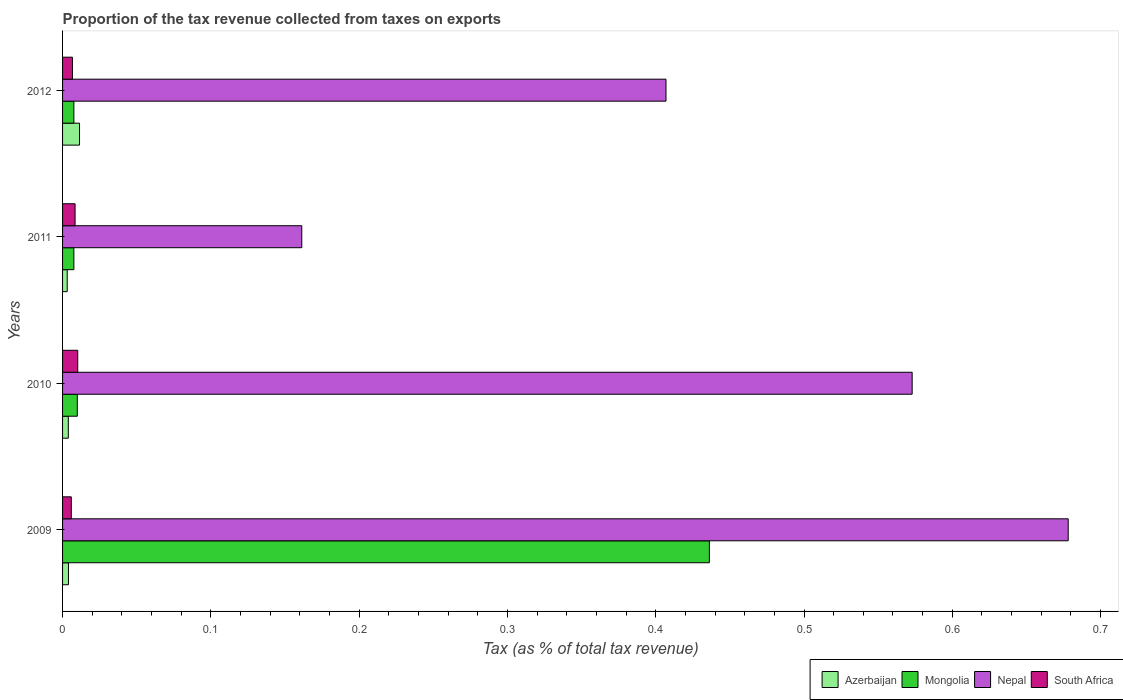Are the number of bars per tick equal to the number of legend labels?
Your answer should be very brief. Yes. Are the number of bars on each tick of the Y-axis equal?
Your answer should be compact. Yes. How many bars are there on the 1st tick from the bottom?
Offer a terse response. 4. What is the proportion of the tax revenue collected in South Africa in 2011?
Offer a terse response. 0.01. Across all years, what is the maximum proportion of the tax revenue collected in South Africa?
Your answer should be compact. 0.01. Across all years, what is the minimum proportion of the tax revenue collected in Mongolia?
Offer a terse response. 0.01. In which year was the proportion of the tax revenue collected in Nepal maximum?
Ensure brevity in your answer.  2009. In which year was the proportion of the tax revenue collected in Nepal minimum?
Your answer should be very brief. 2011. What is the total proportion of the tax revenue collected in Azerbaijan in the graph?
Your answer should be compact. 0.02. What is the difference between the proportion of the tax revenue collected in South Africa in 2010 and that in 2012?
Offer a very short reply. 0. What is the difference between the proportion of the tax revenue collected in Nepal in 2010 and the proportion of the tax revenue collected in South Africa in 2012?
Provide a succinct answer. 0.57. What is the average proportion of the tax revenue collected in Nepal per year?
Offer a very short reply. 0.45. In the year 2010, what is the difference between the proportion of the tax revenue collected in South Africa and proportion of the tax revenue collected in Azerbaijan?
Give a very brief answer. 0.01. What is the ratio of the proportion of the tax revenue collected in Nepal in 2010 to that in 2011?
Keep it short and to the point. 3.55. Is the proportion of the tax revenue collected in South Africa in 2009 less than that in 2011?
Make the answer very short. Yes. Is the difference between the proportion of the tax revenue collected in South Africa in 2010 and 2012 greater than the difference between the proportion of the tax revenue collected in Azerbaijan in 2010 and 2012?
Ensure brevity in your answer.  Yes. What is the difference between the highest and the second highest proportion of the tax revenue collected in Mongolia?
Give a very brief answer. 0.43. What is the difference between the highest and the lowest proportion of the tax revenue collected in South Africa?
Keep it short and to the point. 0. Is the sum of the proportion of the tax revenue collected in South Africa in 2009 and 2010 greater than the maximum proportion of the tax revenue collected in Nepal across all years?
Your response must be concise. No. What does the 2nd bar from the top in 2012 represents?
Give a very brief answer. Nepal. What does the 1st bar from the bottom in 2010 represents?
Ensure brevity in your answer.  Azerbaijan. Are all the bars in the graph horizontal?
Offer a very short reply. Yes. Where does the legend appear in the graph?
Offer a terse response. Bottom right. What is the title of the graph?
Your answer should be compact. Proportion of the tax revenue collected from taxes on exports. What is the label or title of the X-axis?
Provide a succinct answer. Tax (as % of total tax revenue). What is the Tax (as % of total tax revenue) in Azerbaijan in 2009?
Your answer should be compact. 0. What is the Tax (as % of total tax revenue) in Mongolia in 2009?
Give a very brief answer. 0.44. What is the Tax (as % of total tax revenue) in Nepal in 2009?
Give a very brief answer. 0.68. What is the Tax (as % of total tax revenue) in South Africa in 2009?
Make the answer very short. 0.01. What is the Tax (as % of total tax revenue) of Azerbaijan in 2010?
Ensure brevity in your answer.  0. What is the Tax (as % of total tax revenue) of Mongolia in 2010?
Keep it short and to the point. 0.01. What is the Tax (as % of total tax revenue) of Nepal in 2010?
Offer a terse response. 0.57. What is the Tax (as % of total tax revenue) in South Africa in 2010?
Provide a short and direct response. 0.01. What is the Tax (as % of total tax revenue) of Azerbaijan in 2011?
Offer a terse response. 0. What is the Tax (as % of total tax revenue) in Mongolia in 2011?
Ensure brevity in your answer.  0.01. What is the Tax (as % of total tax revenue) of Nepal in 2011?
Your answer should be very brief. 0.16. What is the Tax (as % of total tax revenue) in South Africa in 2011?
Your answer should be compact. 0.01. What is the Tax (as % of total tax revenue) of Azerbaijan in 2012?
Your answer should be compact. 0.01. What is the Tax (as % of total tax revenue) of Mongolia in 2012?
Offer a very short reply. 0.01. What is the Tax (as % of total tax revenue) of Nepal in 2012?
Provide a short and direct response. 0.41. What is the Tax (as % of total tax revenue) of South Africa in 2012?
Your answer should be very brief. 0.01. Across all years, what is the maximum Tax (as % of total tax revenue) of Azerbaijan?
Keep it short and to the point. 0.01. Across all years, what is the maximum Tax (as % of total tax revenue) in Mongolia?
Your response must be concise. 0.44. Across all years, what is the maximum Tax (as % of total tax revenue) in Nepal?
Give a very brief answer. 0.68. Across all years, what is the maximum Tax (as % of total tax revenue) of South Africa?
Give a very brief answer. 0.01. Across all years, what is the minimum Tax (as % of total tax revenue) of Azerbaijan?
Keep it short and to the point. 0. Across all years, what is the minimum Tax (as % of total tax revenue) in Mongolia?
Your response must be concise. 0.01. Across all years, what is the minimum Tax (as % of total tax revenue) of Nepal?
Give a very brief answer. 0.16. Across all years, what is the minimum Tax (as % of total tax revenue) of South Africa?
Offer a very short reply. 0.01. What is the total Tax (as % of total tax revenue) in Azerbaijan in the graph?
Provide a short and direct response. 0.02. What is the total Tax (as % of total tax revenue) of Mongolia in the graph?
Provide a short and direct response. 0.46. What is the total Tax (as % of total tax revenue) in Nepal in the graph?
Make the answer very short. 1.82. What is the total Tax (as % of total tax revenue) of South Africa in the graph?
Ensure brevity in your answer.  0.03. What is the difference between the Tax (as % of total tax revenue) in Azerbaijan in 2009 and that in 2010?
Ensure brevity in your answer.  0. What is the difference between the Tax (as % of total tax revenue) in Mongolia in 2009 and that in 2010?
Offer a very short reply. 0.43. What is the difference between the Tax (as % of total tax revenue) of Nepal in 2009 and that in 2010?
Provide a succinct answer. 0.11. What is the difference between the Tax (as % of total tax revenue) in South Africa in 2009 and that in 2010?
Your response must be concise. -0. What is the difference between the Tax (as % of total tax revenue) of Azerbaijan in 2009 and that in 2011?
Your response must be concise. 0. What is the difference between the Tax (as % of total tax revenue) in Mongolia in 2009 and that in 2011?
Keep it short and to the point. 0.43. What is the difference between the Tax (as % of total tax revenue) in Nepal in 2009 and that in 2011?
Provide a short and direct response. 0.52. What is the difference between the Tax (as % of total tax revenue) of South Africa in 2009 and that in 2011?
Offer a very short reply. -0. What is the difference between the Tax (as % of total tax revenue) of Azerbaijan in 2009 and that in 2012?
Offer a terse response. -0.01. What is the difference between the Tax (as % of total tax revenue) of Mongolia in 2009 and that in 2012?
Make the answer very short. 0.43. What is the difference between the Tax (as % of total tax revenue) of Nepal in 2009 and that in 2012?
Your response must be concise. 0.27. What is the difference between the Tax (as % of total tax revenue) of South Africa in 2009 and that in 2012?
Ensure brevity in your answer.  -0. What is the difference between the Tax (as % of total tax revenue) in Azerbaijan in 2010 and that in 2011?
Ensure brevity in your answer.  0. What is the difference between the Tax (as % of total tax revenue) of Mongolia in 2010 and that in 2011?
Make the answer very short. 0. What is the difference between the Tax (as % of total tax revenue) of Nepal in 2010 and that in 2011?
Provide a short and direct response. 0.41. What is the difference between the Tax (as % of total tax revenue) of South Africa in 2010 and that in 2011?
Give a very brief answer. 0. What is the difference between the Tax (as % of total tax revenue) of Azerbaijan in 2010 and that in 2012?
Ensure brevity in your answer.  -0.01. What is the difference between the Tax (as % of total tax revenue) in Mongolia in 2010 and that in 2012?
Offer a very short reply. 0. What is the difference between the Tax (as % of total tax revenue) in Nepal in 2010 and that in 2012?
Make the answer very short. 0.17. What is the difference between the Tax (as % of total tax revenue) in South Africa in 2010 and that in 2012?
Provide a succinct answer. 0. What is the difference between the Tax (as % of total tax revenue) in Azerbaijan in 2011 and that in 2012?
Your answer should be very brief. -0.01. What is the difference between the Tax (as % of total tax revenue) in Mongolia in 2011 and that in 2012?
Ensure brevity in your answer.  -0. What is the difference between the Tax (as % of total tax revenue) in Nepal in 2011 and that in 2012?
Offer a very short reply. -0.25. What is the difference between the Tax (as % of total tax revenue) of South Africa in 2011 and that in 2012?
Your answer should be very brief. 0. What is the difference between the Tax (as % of total tax revenue) of Azerbaijan in 2009 and the Tax (as % of total tax revenue) of Mongolia in 2010?
Provide a short and direct response. -0.01. What is the difference between the Tax (as % of total tax revenue) in Azerbaijan in 2009 and the Tax (as % of total tax revenue) in Nepal in 2010?
Keep it short and to the point. -0.57. What is the difference between the Tax (as % of total tax revenue) in Azerbaijan in 2009 and the Tax (as % of total tax revenue) in South Africa in 2010?
Offer a terse response. -0.01. What is the difference between the Tax (as % of total tax revenue) in Mongolia in 2009 and the Tax (as % of total tax revenue) in Nepal in 2010?
Offer a very short reply. -0.14. What is the difference between the Tax (as % of total tax revenue) of Mongolia in 2009 and the Tax (as % of total tax revenue) of South Africa in 2010?
Your answer should be very brief. 0.43. What is the difference between the Tax (as % of total tax revenue) of Nepal in 2009 and the Tax (as % of total tax revenue) of South Africa in 2010?
Provide a short and direct response. 0.67. What is the difference between the Tax (as % of total tax revenue) of Azerbaijan in 2009 and the Tax (as % of total tax revenue) of Mongolia in 2011?
Provide a short and direct response. -0. What is the difference between the Tax (as % of total tax revenue) in Azerbaijan in 2009 and the Tax (as % of total tax revenue) in Nepal in 2011?
Your answer should be compact. -0.16. What is the difference between the Tax (as % of total tax revenue) in Azerbaijan in 2009 and the Tax (as % of total tax revenue) in South Africa in 2011?
Offer a very short reply. -0. What is the difference between the Tax (as % of total tax revenue) in Mongolia in 2009 and the Tax (as % of total tax revenue) in Nepal in 2011?
Provide a succinct answer. 0.27. What is the difference between the Tax (as % of total tax revenue) in Mongolia in 2009 and the Tax (as % of total tax revenue) in South Africa in 2011?
Offer a terse response. 0.43. What is the difference between the Tax (as % of total tax revenue) in Nepal in 2009 and the Tax (as % of total tax revenue) in South Africa in 2011?
Offer a terse response. 0.67. What is the difference between the Tax (as % of total tax revenue) of Azerbaijan in 2009 and the Tax (as % of total tax revenue) of Mongolia in 2012?
Ensure brevity in your answer.  -0. What is the difference between the Tax (as % of total tax revenue) in Azerbaijan in 2009 and the Tax (as % of total tax revenue) in Nepal in 2012?
Your answer should be very brief. -0.4. What is the difference between the Tax (as % of total tax revenue) in Azerbaijan in 2009 and the Tax (as % of total tax revenue) in South Africa in 2012?
Provide a succinct answer. -0. What is the difference between the Tax (as % of total tax revenue) in Mongolia in 2009 and the Tax (as % of total tax revenue) in Nepal in 2012?
Offer a very short reply. 0.03. What is the difference between the Tax (as % of total tax revenue) of Mongolia in 2009 and the Tax (as % of total tax revenue) of South Africa in 2012?
Ensure brevity in your answer.  0.43. What is the difference between the Tax (as % of total tax revenue) of Nepal in 2009 and the Tax (as % of total tax revenue) of South Africa in 2012?
Keep it short and to the point. 0.67. What is the difference between the Tax (as % of total tax revenue) in Azerbaijan in 2010 and the Tax (as % of total tax revenue) in Mongolia in 2011?
Your answer should be compact. -0. What is the difference between the Tax (as % of total tax revenue) of Azerbaijan in 2010 and the Tax (as % of total tax revenue) of Nepal in 2011?
Make the answer very short. -0.16. What is the difference between the Tax (as % of total tax revenue) of Azerbaijan in 2010 and the Tax (as % of total tax revenue) of South Africa in 2011?
Offer a terse response. -0. What is the difference between the Tax (as % of total tax revenue) of Mongolia in 2010 and the Tax (as % of total tax revenue) of Nepal in 2011?
Offer a terse response. -0.15. What is the difference between the Tax (as % of total tax revenue) of Mongolia in 2010 and the Tax (as % of total tax revenue) of South Africa in 2011?
Provide a short and direct response. 0. What is the difference between the Tax (as % of total tax revenue) in Nepal in 2010 and the Tax (as % of total tax revenue) in South Africa in 2011?
Provide a succinct answer. 0.56. What is the difference between the Tax (as % of total tax revenue) in Azerbaijan in 2010 and the Tax (as % of total tax revenue) in Mongolia in 2012?
Your answer should be very brief. -0. What is the difference between the Tax (as % of total tax revenue) of Azerbaijan in 2010 and the Tax (as % of total tax revenue) of Nepal in 2012?
Your response must be concise. -0.4. What is the difference between the Tax (as % of total tax revenue) of Azerbaijan in 2010 and the Tax (as % of total tax revenue) of South Africa in 2012?
Ensure brevity in your answer.  -0. What is the difference between the Tax (as % of total tax revenue) of Mongolia in 2010 and the Tax (as % of total tax revenue) of Nepal in 2012?
Your response must be concise. -0.4. What is the difference between the Tax (as % of total tax revenue) of Mongolia in 2010 and the Tax (as % of total tax revenue) of South Africa in 2012?
Your answer should be very brief. 0. What is the difference between the Tax (as % of total tax revenue) in Nepal in 2010 and the Tax (as % of total tax revenue) in South Africa in 2012?
Offer a terse response. 0.57. What is the difference between the Tax (as % of total tax revenue) of Azerbaijan in 2011 and the Tax (as % of total tax revenue) of Mongolia in 2012?
Give a very brief answer. -0. What is the difference between the Tax (as % of total tax revenue) of Azerbaijan in 2011 and the Tax (as % of total tax revenue) of Nepal in 2012?
Provide a succinct answer. -0.4. What is the difference between the Tax (as % of total tax revenue) of Azerbaijan in 2011 and the Tax (as % of total tax revenue) of South Africa in 2012?
Give a very brief answer. -0. What is the difference between the Tax (as % of total tax revenue) of Mongolia in 2011 and the Tax (as % of total tax revenue) of Nepal in 2012?
Ensure brevity in your answer.  -0.4. What is the difference between the Tax (as % of total tax revenue) in Nepal in 2011 and the Tax (as % of total tax revenue) in South Africa in 2012?
Offer a very short reply. 0.15. What is the average Tax (as % of total tax revenue) of Azerbaijan per year?
Ensure brevity in your answer.  0.01. What is the average Tax (as % of total tax revenue) of Mongolia per year?
Make the answer very short. 0.12. What is the average Tax (as % of total tax revenue) of Nepal per year?
Keep it short and to the point. 0.45. What is the average Tax (as % of total tax revenue) in South Africa per year?
Offer a terse response. 0.01. In the year 2009, what is the difference between the Tax (as % of total tax revenue) of Azerbaijan and Tax (as % of total tax revenue) of Mongolia?
Make the answer very short. -0.43. In the year 2009, what is the difference between the Tax (as % of total tax revenue) of Azerbaijan and Tax (as % of total tax revenue) of Nepal?
Ensure brevity in your answer.  -0.67. In the year 2009, what is the difference between the Tax (as % of total tax revenue) in Azerbaijan and Tax (as % of total tax revenue) in South Africa?
Keep it short and to the point. -0. In the year 2009, what is the difference between the Tax (as % of total tax revenue) in Mongolia and Tax (as % of total tax revenue) in Nepal?
Make the answer very short. -0.24. In the year 2009, what is the difference between the Tax (as % of total tax revenue) of Mongolia and Tax (as % of total tax revenue) of South Africa?
Your answer should be very brief. 0.43. In the year 2009, what is the difference between the Tax (as % of total tax revenue) in Nepal and Tax (as % of total tax revenue) in South Africa?
Offer a very short reply. 0.67. In the year 2010, what is the difference between the Tax (as % of total tax revenue) of Azerbaijan and Tax (as % of total tax revenue) of Mongolia?
Provide a short and direct response. -0.01. In the year 2010, what is the difference between the Tax (as % of total tax revenue) in Azerbaijan and Tax (as % of total tax revenue) in Nepal?
Ensure brevity in your answer.  -0.57. In the year 2010, what is the difference between the Tax (as % of total tax revenue) of Azerbaijan and Tax (as % of total tax revenue) of South Africa?
Offer a very short reply. -0.01. In the year 2010, what is the difference between the Tax (as % of total tax revenue) of Mongolia and Tax (as % of total tax revenue) of Nepal?
Your answer should be very brief. -0.56. In the year 2010, what is the difference between the Tax (as % of total tax revenue) of Mongolia and Tax (as % of total tax revenue) of South Africa?
Your answer should be compact. -0. In the year 2010, what is the difference between the Tax (as % of total tax revenue) in Nepal and Tax (as % of total tax revenue) in South Africa?
Your answer should be very brief. 0.56. In the year 2011, what is the difference between the Tax (as % of total tax revenue) of Azerbaijan and Tax (as % of total tax revenue) of Mongolia?
Your answer should be compact. -0. In the year 2011, what is the difference between the Tax (as % of total tax revenue) of Azerbaijan and Tax (as % of total tax revenue) of Nepal?
Make the answer very short. -0.16. In the year 2011, what is the difference between the Tax (as % of total tax revenue) in Azerbaijan and Tax (as % of total tax revenue) in South Africa?
Ensure brevity in your answer.  -0.01. In the year 2011, what is the difference between the Tax (as % of total tax revenue) of Mongolia and Tax (as % of total tax revenue) of Nepal?
Your answer should be compact. -0.15. In the year 2011, what is the difference between the Tax (as % of total tax revenue) of Mongolia and Tax (as % of total tax revenue) of South Africa?
Your answer should be very brief. -0. In the year 2011, what is the difference between the Tax (as % of total tax revenue) in Nepal and Tax (as % of total tax revenue) in South Africa?
Your answer should be compact. 0.15. In the year 2012, what is the difference between the Tax (as % of total tax revenue) in Azerbaijan and Tax (as % of total tax revenue) in Mongolia?
Provide a short and direct response. 0. In the year 2012, what is the difference between the Tax (as % of total tax revenue) of Azerbaijan and Tax (as % of total tax revenue) of Nepal?
Offer a terse response. -0.4. In the year 2012, what is the difference between the Tax (as % of total tax revenue) in Azerbaijan and Tax (as % of total tax revenue) in South Africa?
Provide a short and direct response. 0. In the year 2012, what is the difference between the Tax (as % of total tax revenue) in Mongolia and Tax (as % of total tax revenue) in Nepal?
Provide a succinct answer. -0.4. In the year 2012, what is the difference between the Tax (as % of total tax revenue) of Mongolia and Tax (as % of total tax revenue) of South Africa?
Your answer should be compact. 0. In the year 2012, what is the difference between the Tax (as % of total tax revenue) of Nepal and Tax (as % of total tax revenue) of South Africa?
Ensure brevity in your answer.  0.4. What is the ratio of the Tax (as % of total tax revenue) of Azerbaijan in 2009 to that in 2010?
Ensure brevity in your answer.  1.03. What is the ratio of the Tax (as % of total tax revenue) in Mongolia in 2009 to that in 2010?
Provide a succinct answer. 43.93. What is the ratio of the Tax (as % of total tax revenue) of Nepal in 2009 to that in 2010?
Your answer should be compact. 1.18. What is the ratio of the Tax (as % of total tax revenue) in South Africa in 2009 to that in 2010?
Your answer should be very brief. 0.58. What is the ratio of the Tax (as % of total tax revenue) of Azerbaijan in 2009 to that in 2011?
Offer a terse response. 1.27. What is the ratio of the Tax (as % of total tax revenue) in Mongolia in 2009 to that in 2011?
Offer a terse response. 57.21. What is the ratio of the Tax (as % of total tax revenue) of Nepal in 2009 to that in 2011?
Give a very brief answer. 4.2. What is the ratio of the Tax (as % of total tax revenue) in South Africa in 2009 to that in 2011?
Your answer should be compact. 0.7. What is the ratio of the Tax (as % of total tax revenue) in Azerbaijan in 2009 to that in 2012?
Your response must be concise. 0.35. What is the ratio of the Tax (as % of total tax revenue) in Mongolia in 2009 to that in 2012?
Give a very brief answer. 57.09. What is the ratio of the Tax (as % of total tax revenue) in Nepal in 2009 to that in 2012?
Provide a short and direct response. 1.67. What is the ratio of the Tax (as % of total tax revenue) in South Africa in 2009 to that in 2012?
Make the answer very short. 0.88. What is the ratio of the Tax (as % of total tax revenue) of Azerbaijan in 2010 to that in 2011?
Make the answer very short. 1.23. What is the ratio of the Tax (as % of total tax revenue) of Mongolia in 2010 to that in 2011?
Your response must be concise. 1.3. What is the ratio of the Tax (as % of total tax revenue) in Nepal in 2010 to that in 2011?
Your answer should be compact. 3.55. What is the ratio of the Tax (as % of total tax revenue) of South Africa in 2010 to that in 2011?
Give a very brief answer. 1.21. What is the ratio of the Tax (as % of total tax revenue) in Azerbaijan in 2010 to that in 2012?
Keep it short and to the point. 0.34. What is the ratio of the Tax (as % of total tax revenue) in Mongolia in 2010 to that in 2012?
Make the answer very short. 1.3. What is the ratio of the Tax (as % of total tax revenue) in Nepal in 2010 to that in 2012?
Provide a short and direct response. 1.41. What is the ratio of the Tax (as % of total tax revenue) of South Africa in 2010 to that in 2012?
Make the answer very short. 1.54. What is the ratio of the Tax (as % of total tax revenue) in Azerbaijan in 2011 to that in 2012?
Your answer should be compact. 0.27. What is the ratio of the Tax (as % of total tax revenue) in Mongolia in 2011 to that in 2012?
Your response must be concise. 1. What is the ratio of the Tax (as % of total tax revenue) of Nepal in 2011 to that in 2012?
Your response must be concise. 0.4. What is the ratio of the Tax (as % of total tax revenue) of South Africa in 2011 to that in 2012?
Ensure brevity in your answer.  1.27. What is the difference between the highest and the second highest Tax (as % of total tax revenue) of Azerbaijan?
Your answer should be compact. 0.01. What is the difference between the highest and the second highest Tax (as % of total tax revenue) of Mongolia?
Keep it short and to the point. 0.43. What is the difference between the highest and the second highest Tax (as % of total tax revenue) of Nepal?
Offer a very short reply. 0.11. What is the difference between the highest and the second highest Tax (as % of total tax revenue) of South Africa?
Offer a terse response. 0. What is the difference between the highest and the lowest Tax (as % of total tax revenue) of Azerbaijan?
Make the answer very short. 0.01. What is the difference between the highest and the lowest Tax (as % of total tax revenue) of Mongolia?
Give a very brief answer. 0.43. What is the difference between the highest and the lowest Tax (as % of total tax revenue) of Nepal?
Your answer should be compact. 0.52. What is the difference between the highest and the lowest Tax (as % of total tax revenue) of South Africa?
Your answer should be very brief. 0. 